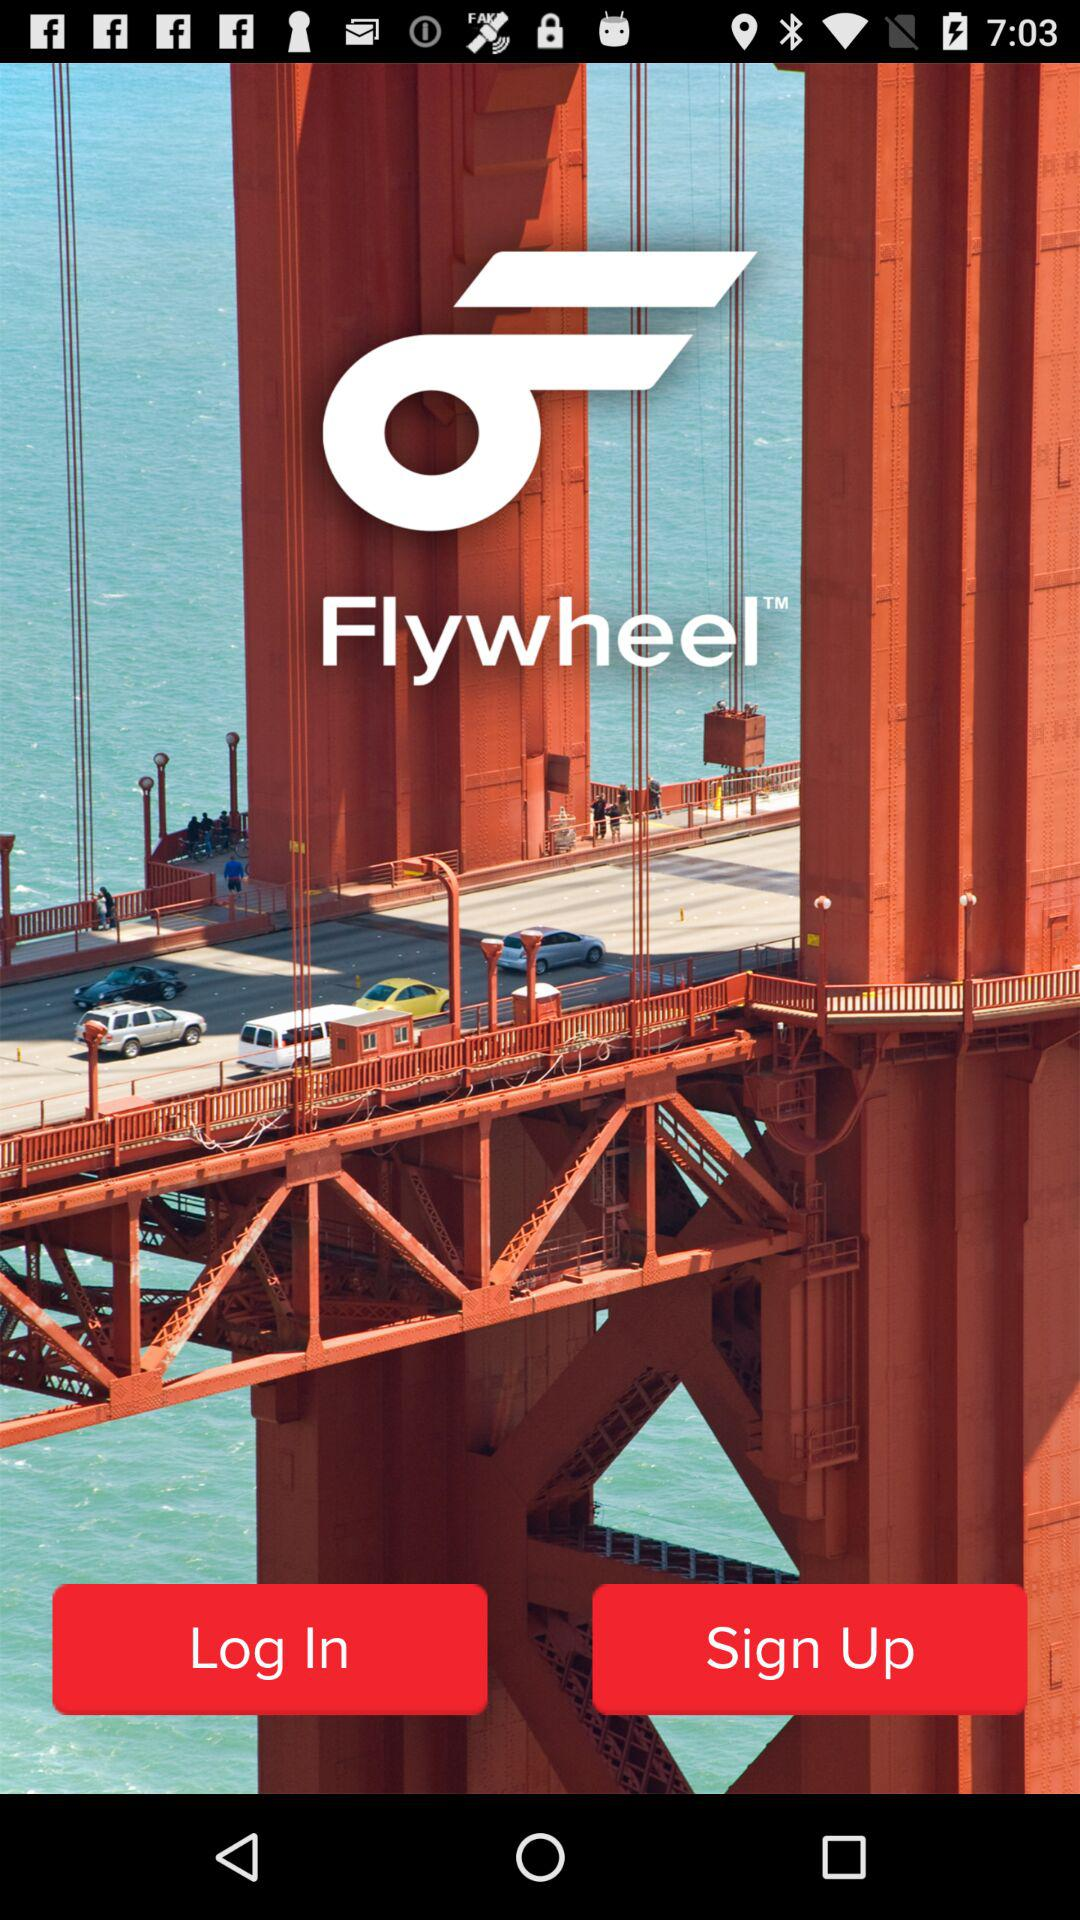What version of the application is being used?
When the provided information is insufficient, respond with <no answer>. <no answer> 